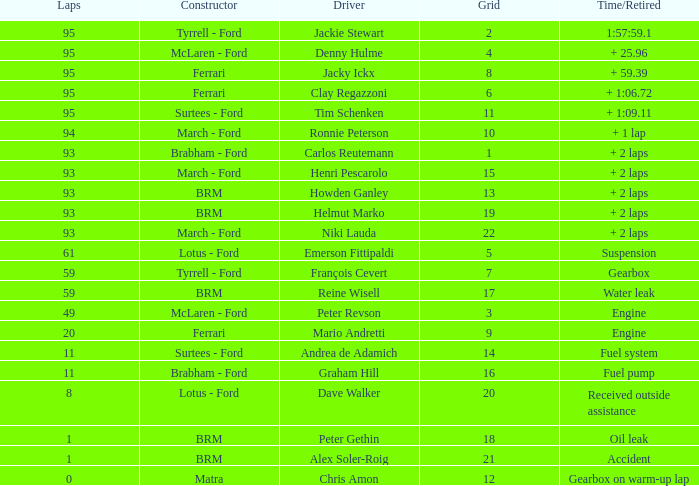Which grid has less than 11 laps, and a Time/Retired of accident? 21.0. 